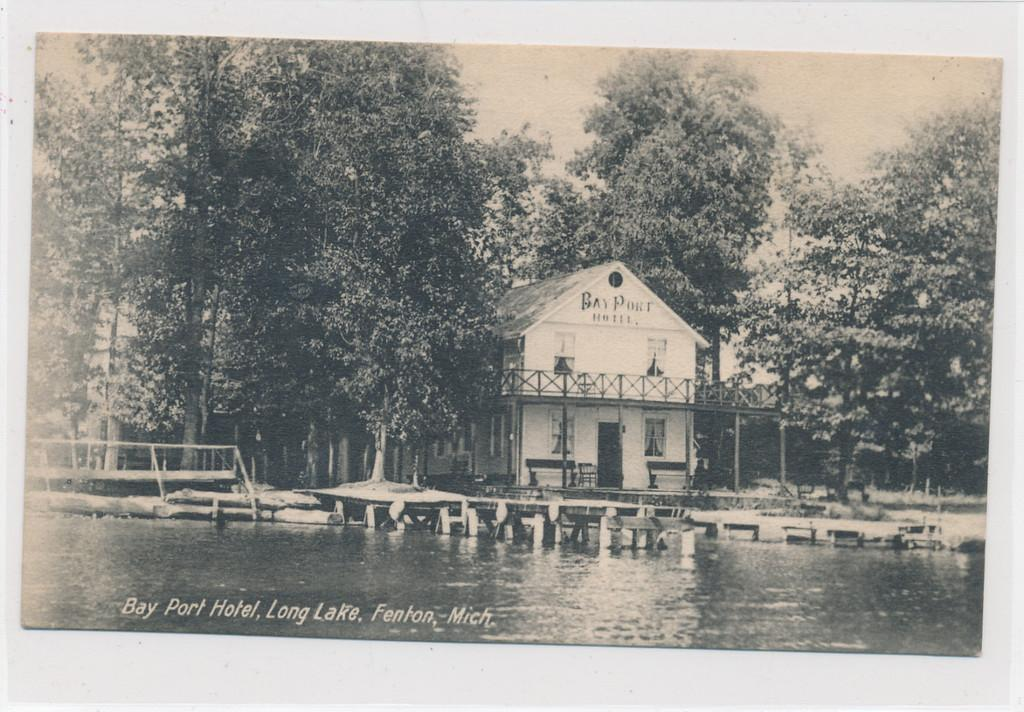What is the color scheme of the image? The image is black and white. What is the main subject in the middle of the image? There is a home in the middle of the image. What type of vegetation surrounds the home? There are trees on either side of the home. What body of water is present in front of the home? There is a pond in front of the home. What type of pest can be seen crawling on the judge's robe in the image? There is no judge or pest present in the image; it features a home with trees and a pond. 